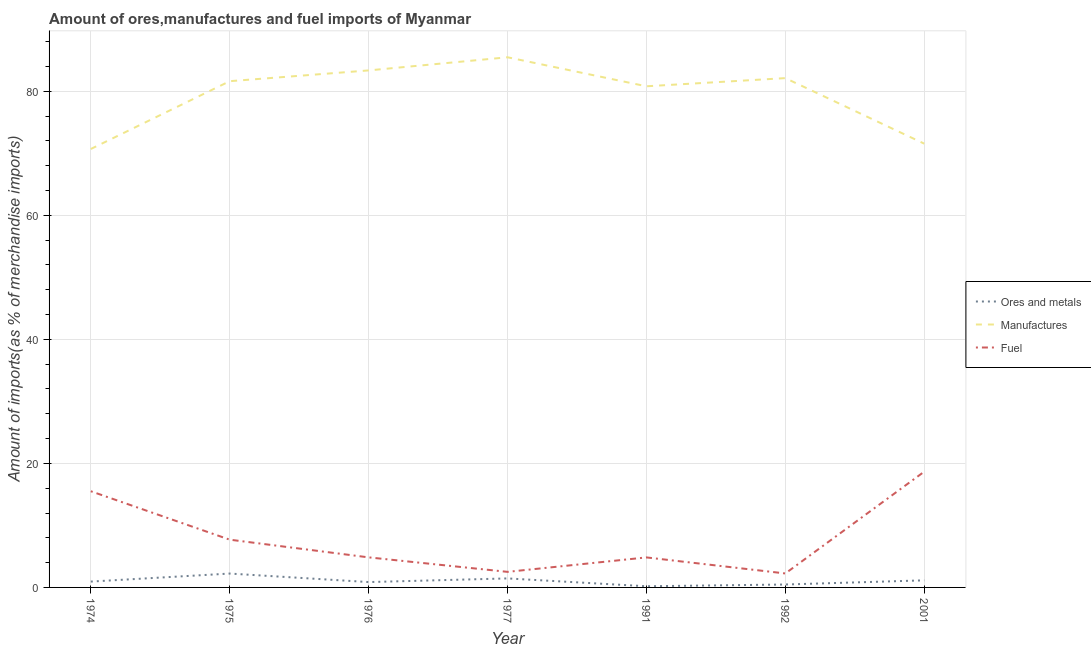Is the number of lines equal to the number of legend labels?
Make the answer very short. Yes. What is the percentage of manufactures imports in 1977?
Keep it short and to the point. 85.5. Across all years, what is the maximum percentage of ores and metals imports?
Your response must be concise. 2.24. Across all years, what is the minimum percentage of ores and metals imports?
Offer a very short reply. 0.19. In which year was the percentage of ores and metals imports maximum?
Your answer should be compact. 1975. In which year was the percentage of ores and metals imports minimum?
Your response must be concise. 1991. What is the total percentage of ores and metals imports in the graph?
Offer a terse response. 7.3. What is the difference between the percentage of ores and metals imports in 1977 and that in 1991?
Offer a very short reply. 1.27. What is the difference between the percentage of manufactures imports in 1975 and the percentage of fuel imports in 1991?
Your answer should be very brief. 76.8. What is the average percentage of manufactures imports per year?
Offer a very short reply. 79.39. In the year 1975, what is the difference between the percentage of manufactures imports and percentage of fuel imports?
Offer a terse response. 73.94. In how many years, is the percentage of ores and metals imports greater than 68 %?
Make the answer very short. 0. What is the ratio of the percentage of manufactures imports in 1976 to that in 1977?
Your answer should be compact. 0.98. Is the difference between the percentage of fuel imports in 1975 and 2001 greater than the difference between the percentage of ores and metals imports in 1975 and 2001?
Provide a short and direct response. No. What is the difference between the highest and the second highest percentage of ores and metals imports?
Keep it short and to the point. 0.78. What is the difference between the highest and the lowest percentage of manufactures imports?
Your answer should be compact. 14.79. Is it the case that in every year, the sum of the percentage of ores and metals imports and percentage of manufactures imports is greater than the percentage of fuel imports?
Your answer should be very brief. Yes. Does the percentage of manufactures imports monotonically increase over the years?
Keep it short and to the point. No. Is the percentage of manufactures imports strictly greater than the percentage of ores and metals imports over the years?
Ensure brevity in your answer.  Yes. How many lines are there?
Provide a succinct answer. 3. Are the values on the major ticks of Y-axis written in scientific E-notation?
Give a very brief answer. No. Does the graph contain grids?
Provide a short and direct response. Yes. How many legend labels are there?
Keep it short and to the point. 3. What is the title of the graph?
Ensure brevity in your answer.  Amount of ores,manufactures and fuel imports of Myanmar. What is the label or title of the Y-axis?
Your answer should be very brief. Amount of imports(as % of merchandise imports). What is the Amount of imports(as % of merchandise imports) of Ores and metals in 1974?
Make the answer very short. 0.94. What is the Amount of imports(as % of merchandise imports) in Manufactures in 1974?
Ensure brevity in your answer.  70.7. What is the Amount of imports(as % of merchandise imports) in Fuel in 1974?
Offer a very short reply. 15.51. What is the Amount of imports(as % of merchandise imports) in Ores and metals in 1975?
Your response must be concise. 2.24. What is the Amount of imports(as % of merchandise imports) in Manufactures in 1975?
Keep it short and to the point. 81.64. What is the Amount of imports(as % of merchandise imports) of Fuel in 1975?
Your response must be concise. 7.7. What is the Amount of imports(as % of merchandise imports) of Ores and metals in 1976?
Offer a terse response. 0.86. What is the Amount of imports(as % of merchandise imports) in Manufactures in 1976?
Offer a very short reply. 83.38. What is the Amount of imports(as % of merchandise imports) of Fuel in 1976?
Make the answer very short. 4.85. What is the Amount of imports(as % of merchandise imports) in Ores and metals in 1977?
Offer a terse response. 1.45. What is the Amount of imports(as % of merchandise imports) of Manufactures in 1977?
Provide a succinct answer. 85.5. What is the Amount of imports(as % of merchandise imports) in Fuel in 1977?
Your answer should be compact. 2.51. What is the Amount of imports(as % of merchandise imports) in Ores and metals in 1991?
Keep it short and to the point. 0.19. What is the Amount of imports(as % of merchandise imports) in Manufactures in 1991?
Your answer should be compact. 80.82. What is the Amount of imports(as % of merchandise imports) in Fuel in 1991?
Your answer should be compact. 4.84. What is the Amount of imports(as % of merchandise imports) in Ores and metals in 1992?
Offer a terse response. 0.47. What is the Amount of imports(as % of merchandise imports) in Manufactures in 1992?
Your answer should be very brief. 82.13. What is the Amount of imports(as % of merchandise imports) in Fuel in 1992?
Your answer should be very brief. 2.25. What is the Amount of imports(as % of merchandise imports) in Ores and metals in 2001?
Keep it short and to the point. 1.14. What is the Amount of imports(as % of merchandise imports) in Manufactures in 2001?
Your answer should be compact. 71.57. What is the Amount of imports(as % of merchandise imports) of Fuel in 2001?
Your answer should be compact. 18.67. Across all years, what is the maximum Amount of imports(as % of merchandise imports) in Ores and metals?
Offer a very short reply. 2.24. Across all years, what is the maximum Amount of imports(as % of merchandise imports) of Manufactures?
Provide a short and direct response. 85.5. Across all years, what is the maximum Amount of imports(as % of merchandise imports) in Fuel?
Offer a terse response. 18.67. Across all years, what is the minimum Amount of imports(as % of merchandise imports) in Ores and metals?
Your answer should be compact. 0.19. Across all years, what is the minimum Amount of imports(as % of merchandise imports) of Manufactures?
Offer a terse response. 70.7. Across all years, what is the minimum Amount of imports(as % of merchandise imports) of Fuel?
Give a very brief answer. 2.25. What is the total Amount of imports(as % of merchandise imports) in Ores and metals in the graph?
Offer a terse response. 7.3. What is the total Amount of imports(as % of merchandise imports) in Manufactures in the graph?
Keep it short and to the point. 555.73. What is the total Amount of imports(as % of merchandise imports) in Fuel in the graph?
Ensure brevity in your answer.  56.33. What is the difference between the Amount of imports(as % of merchandise imports) of Ores and metals in 1974 and that in 1975?
Provide a succinct answer. -1.29. What is the difference between the Amount of imports(as % of merchandise imports) of Manufactures in 1974 and that in 1975?
Give a very brief answer. -10.94. What is the difference between the Amount of imports(as % of merchandise imports) of Fuel in 1974 and that in 1975?
Give a very brief answer. 7.81. What is the difference between the Amount of imports(as % of merchandise imports) in Ores and metals in 1974 and that in 1976?
Your answer should be very brief. 0.08. What is the difference between the Amount of imports(as % of merchandise imports) in Manufactures in 1974 and that in 1976?
Your response must be concise. -12.67. What is the difference between the Amount of imports(as % of merchandise imports) in Fuel in 1974 and that in 1976?
Provide a short and direct response. 10.66. What is the difference between the Amount of imports(as % of merchandise imports) of Ores and metals in 1974 and that in 1977?
Offer a terse response. -0.51. What is the difference between the Amount of imports(as % of merchandise imports) of Manufactures in 1974 and that in 1977?
Ensure brevity in your answer.  -14.79. What is the difference between the Amount of imports(as % of merchandise imports) of Fuel in 1974 and that in 1977?
Give a very brief answer. 13. What is the difference between the Amount of imports(as % of merchandise imports) in Ores and metals in 1974 and that in 1991?
Provide a short and direct response. 0.75. What is the difference between the Amount of imports(as % of merchandise imports) in Manufactures in 1974 and that in 1991?
Offer a terse response. -10.11. What is the difference between the Amount of imports(as % of merchandise imports) in Fuel in 1974 and that in 1991?
Ensure brevity in your answer.  10.67. What is the difference between the Amount of imports(as % of merchandise imports) of Ores and metals in 1974 and that in 1992?
Offer a terse response. 0.47. What is the difference between the Amount of imports(as % of merchandise imports) in Manufactures in 1974 and that in 1992?
Your answer should be compact. -11.43. What is the difference between the Amount of imports(as % of merchandise imports) in Fuel in 1974 and that in 1992?
Keep it short and to the point. 13.26. What is the difference between the Amount of imports(as % of merchandise imports) in Ores and metals in 1974 and that in 2001?
Offer a very short reply. -0.2. What is the difference between the Amount of imports(as % of merchandise imports) of Manufactures in 1974 and that in 2001?
Ensure brevity in your answer.  -0.86. What is the difference between the Amount of imports(as % of merchandise imports) of Fuel in 1974 and that in 2001?
Provide a short and direct response. -3.16. What is the difference between the Amount of imports(as % of merchandise imports) in Ores and metals in 1975 and that in 1976?
Provide a short and direct response. 1.37. What is the difference between the Amount of imports(as % of merchandise imports) of Manufactures in 1975 and that in 1976?
Your answer should be compact. -1.74. What is the difference between the Amount of imports(as % of merchandise imports) in Fuel in 1975 and that in 1976?
Offer a very short reply. 2.85. What is the difference between the Amount of imports(as % of merchandise imports) in Ores and metals in 1975 and that in 1977?
Keep it short and to the point. 0.78. What is the difference between the Amount of imports(as % of merchandise imports) in Manufactures in 1975 and that in 1977?
Offer a terse response. -3.86. What is the difference between the Amount of imports(as % of merchandise imports) of Fuel in 1975 and that in 1977?
Keep it short and to the point. 5.19. What is the difference between the Amount of imports(as % of merchandise imports) of Ores and metals in 1975 and that in 1991?
Make the answer very short. 2.05. What is the difference between the Amount of imports(as % of merchandise imports) of Manufactures in 1975 and that in 1991?
Provide a short and direct response. 0.82. What is the difference between the Amount of imports(as % of merchandise imports) in Fuel in 1975 and that in 1991?
Offer a terse response. 2.86. What is the difference between the Amount of imports(as % of merchandise imports) in Ores and metals in 1975 and that in 1992?
Your response must be concise. 1.77. What is the difference between the Amount of imports(as % of merchandise imports) in Manufactures in 1975 and that in 1992?
Provide a succinct answer. -0.49. What is the difference between the Amount of imports(as % of merchandise imports) in Fuel in 1975 and that in 1992?
Your answer should be compact. 5.45. What is the difference between the Amount of imports(as % of merchandise imports) of Ores and metals in 1975 and that in 2001?
Keep it short and to the point. 1.09. What is the difference between the Amount of imports(as % of merchandise imports) of Manufactures in 1975 and that in 2001?
Provide a succinct answer. 10.07. What is the difference between the Amount of imports(as % of merchandise imports) in Fuel in 1975 and that in 2001?
Your answer should be compact. -10.97. What is the difference between the Amount of imports(as % of merchandise imports) in Ores and metals in 1976 and that in 1977?
Offer a terse response. -0.59. What is the difference between the Amount of imports(as % of merchandise imports) of Manufactures in 1976 and that in 1977?
Your response must be concise. -2.12. What is the difference between the Amount of imports(as % of merchandise imports) of Fuel in 1976 and that in 1977?
Provide a succinct answer. 2.34. What is the difference between the Amount of imports(as % of merchandise imports) in Ores and metals in 1976 and that in 1991?
Offer a terse response. 0.68. What is the difference between the Amount of imports(as % of merchandise imports) of Manufactures in 1976 and that in 1991?
Provide a succinct answer. 2.56. What is the difference between the Amount of imports(as % of merchandise imports) in Fuel in 1976 and that in 1991?
Offer a very short reply. 0.01. What is the difference between the Amount of imports(as % of merchandise imports) of Ores and metals in 1976 and that in 1992?
Your answer should be very brief. 0.39. What is the difference between the Amount of imports(as % of merchandise imports) in Manufactures in 1976 and that in 1992?
Give a very brief answer. 1.24. What is the difference between the Amount of imports(as % of merchandise imports) in Fuel in 1976 and that in 1992?
Your answer should be compact. 2.59. What is the difference between the Amount of imports(as % of merchandise imports) in Ores and metals in 1976 and that in 2001?
Ensure brevity in your answer.  -0.28. What is the difference between the Amount of imports(as % of merchandise imports) of Manufactures in 1976 and that in 2001?
Keep it short and to the point. 11.81. What is the difference between the Amount of imports(as % of merchandise imports) of Fuel in 1976 and that in 2001?
Make the answer very short. -13.82. What is the difference between the Amount of imports(as % of merchandise imports) in Ores and metals in 1977 and that in 1991?
Provide a short and direct response. 1.27. What is the difference between the Amount of imports(as % of merchandise imports) in Manufactures in 1977 and that in 1991?
Make the answer very short. 4.68. What is the difference between the Amount of imports(as % of merchandise imports) in Fuel in 1977 and that in 1991?
Ensure brevity in your answer.  -2.33. What is the difference between the Amount of imports(as % of merchandise imports) in Ores and metals in 1977 and that in 1992?
Offer a very short reply. 0.98. What is the difference between the Amount of imports(as % of merchandise imports) of Manufactures in 1977 and that in 1992?
Provide a short and direct response. 3.36. What is the difference between the Amount of imports(as % of merchandise imports) in Fuel in 1977 and that in 1992?
Your response must be concise. 0.26. What is the difference between the Amount of imports(as % of merchandise imports) in Ores and metals in 1977 and that in 2001?
Keep it short and to the point. 0.31. What is the difference between the Amount of imports(as % of merchandise imports) of Manufactures in 1977 and that in 2001?
Ensure brevity in your answer.  13.93. What is the difference between the Amount of imports(as % of merchandise imports) of Fuel in 1977 and that in 2001?
Your answer should be very brief. -16.16. What is the difference between the Amount of imports(as % of merchandise imports) in Ores and metals in 1991 and that in 1992?
Give a very brief answer. -0.28. What is the difference between the Amount of imports(as % of merchandise imports) in Manufactures in 1991 and that in 1992?
Your answer should be very brief. -1.32. What is the difference between the Amount of imports(as % of merchandise imports) of Fuel in 1991 and that in 1992?
Provide a short and direct response. 2.59. What is the difference between the Amount of imports(as % of merchandise imports) of Ores and metals in 1991 and that in 2001?
Provide a short and direct response. -0.95. What is the difference between the Amount of imports(as % of merchandise imports) of Manufactures in 1991 and that in 2001?
Make the answer very short. 9.25. What is the difference between the Amount of imports(as % of merchandise imports) in Fuel in 1991 and that in 2001?
Keep it short and to the point. -13.83. What is the difference between the Amount of imports(as % of merchandise imports) in Ores and metals in 1992 and that in 2001?
Your response must be concise. -0.67. What is the difference between the Amount of imports(as % of merchandise imports) of Manufactures in 1992 and that in 2001?
Offer a very short reply. 10.57. What is the difference between the Amount of imports(as % of merchandise imports) of Fuel in 1992 and that in 2001?
Provide a succinct answer. -16.42. What is the difference between the Amount of imports(as % of merchandise imports) of Ores and metals in 1974 and the Amount of imports(as % of merchandise imports) of Manufactures in 1975?
Provide a succinct answer. -80.7. What is the difference between the Amount of imports(as % of merchandise imports) of Ores and metals in 1974 and the Amount of imports(as % of merchandise imports) of Fuel in 1975?
Your answer should be very brief. -6.76. What is the difference between the Amount of imports(as % of merchandise imports) of Manufactures in 1974 and the Amount of imports(as % of merchandise imports) of Fuel in 1975?
Keep it short and to the point. 63. What is the difference between the Amount of imports(as % of merchandise imports) of Ores and metals in 1974 and the Amount of imports(as % of merchandise imports) of Manufactures in 1976?
Give a very brief answer. -82.43. What is the difference between the Amount of imports(as % of merchandise imports) in Ores and metals in 1974 and the Amount of imports(as % of merchandise imports) in Fuel in 1976?
Your answer should be very brief. -3.91. What is the difference between the Amount of imports(as % of merchandise imports) of Manufactures in 1974 and the Amount of imports(as % of merchandise imports) of Fuel in 1976?
Your answer should be compact. 65.86. What is the difference between the Amount of imports(as % of merchandise imports) in Ores and metals in 1974 and the Amount of imports(as % of merchandise imports) in Manufactures in 1977?
Your answer should be very brief. -84.55. What is the difference between the Amount of imports(as % of merchandise imports) of Ores and metals in 1974 and the Amount of imports(as % of merchandise imports) of Fuel in 1977?
Provide a short and direct response. -1.57. What is the difference between the Amount of imports(as % of merchandise imports) of Manufactures in 1974 and the Amount of imports(as % of merchandise imports) of Fuel in 1977?
Keep it short and to the point. 68.19. What is the difference between the Amount of imports(as % of merchandise imports) of Ores and metals in 1974 and the Amount of imports(as % of merchandise imports) of Manufactures in 1991?
Make the answer very short. -79.88. What is the difference between the Amount of imports(as % of merchandise imports) in Ores and metals in 1974 and the Amount of imports(as % of merchandise imports) in Fuel in 1991?
Provide a succinct answer. -3.9. What is the difference between the Amount of imports(as % of merchandise imports) in Manufactures in 1974 and the Amount of imports(as % of merchandise imports) in Fuel in 1991?
Your answer should be very brief. 65.86. What is the difference between the Amount of imports(as % of merchandise imports) of Ores and metals in 1974 and the Amount of imports(as % of merchandise imports) of Manufactures in 1992?
Give a very brief answer. -81.19. What is the difference between the Amount of imports(as % of merchandise imports) in Ores and metals in 1974 and the Amount of imports(as % of merchandise imports) in Fuel in 1992?
Give a very brief answer. -1.31. What is the difference between the Amount of imports(as % of merchandise imports) of Manufactures in 1974 and the Amount of imports(as % of merchandise imports) of Fuel in 1992?
Ensure brevity in your answer.  68.45. What is the difference between the Amount of imports(as % of merchandise imports) in Ores and metals in 1974 and the Amount of imports(as % of merchandise imports) in Manufactures in 2001?
Provide a short and direct response. -70.62. What is the difference between the Amount of imports(as % of merchandise imports) in Ores and metals in 1974 and the Amount of imports(as % of merchandise imports) in Fuel in 2001?
Provide a short and direct response. -17.73. What is the difference between the Amount of imports(as % of merchandise imports) of Manufactures in 1974 and the Amount of imports(as % of merchandise imports) of Fuel in 2001?
Offer a very short reply. 52.04. What is the difference between the Amount of imports(as % of merchandise imports) in Ores and metals in 1975 and the Amount of imports(as % of merchandise imports) in Manufactures in 1976?
Keep it short and to the point. -81.14. What is the difference between the Amount of imports(as % of merchandise imports) in Ores and metals in 1975 and the Amount of imports(as % of merchandise imports) in Fuel in 1976?
Your response must be concise. -2.61. What is the difference between the Amount of imports(as % of merchandise imports) of Manufactures in 1975 and the Amount of imports(as % of merchandise imports) of Fuel in 1976?
Offer a very short reply. 76.79. What is the difference between the Amount of imports(as % of merchandise imports) in Ores and metals in 1975 and the Amount of imports(as % of merchandise imports) in Manufactures in 1977?
Ensure brevity in your answer.  -83.26. What is the difference between the Amount of imports(as % of merchandise imports) of Ores and metals in 1975 and the Amount of imports(as % of merchandise imports) of Fuel in 1977?
Keep it short and to the point. -0.27. What is the difference between the Amount of imports(as % of merchandise imports) in Manufactures in 1975 and the Amount of imports(as % of merchandise imports) in Fuel in 1977?
Keep it short and to the point. 79.13. What is the difference between the Amount of imports(as % of merchandise imports) of Ores and metals in 1975 and the Amount of imports(as % of merchandise imports) of Manufactures in 1991?
Your response must be concise. -78.58. What is the difference between the Amount of imports(as % of merchandise imports) in Ores and metals in 1975 and the Amount of imports(as % of merchandise imports) in Fuel in 1991?
Provide a short and direct response. -2.6. What is the difference between the Amount of imports(as % of merchandise imports) of Manufactures in 1975 and the Amount of imports(as % of merchandise imports) of Fuel in 1991?
Provide a short and direct response. 76.8. What is the difference between the Amount of imports(as % of merchandise imports) in Ores and metals in 1975 and the Amount of imports(as % of merchandise imports) in Manufactures in 1992?
Offer a terse response. -79.9. What is the difference between the Amount of imports(as % of merchandise imports) of Ores and metals in 1975 and the Amount of imports(as % of merchandise imports) of Fuel in 1992?
Your response must be concise. -0.02. What is the difference between the Amount of imports(as % of merchandise imports) of Manufactures in 1975 and the Amount of imports(as % of merchandise imports) of Fuel in 1992?
Your response must be concise. 79.39. What is the difference between the Amount of imports(as % of merchandise imports) of Ores and metals in 1975 and the Amount of imports(as % of merchandise imports) of Manufactures in 2001?
Your answer should be compact. -69.33. What is the difference between the Amount of imports(as % of merchandise imports) of Ores and metals in 1975 and the Amount of imports(as % of merchandise imports) of Fuel in 2001?
Ensure brevity in your answer.  -16.43. What is the difference between the Amount of imports(as % of merchandise imports) in Manufactures in 1975 and the Amount of imports(as % of merchandise imports) in Fuel in 2001?
Your answer should be very brief. 62.97. What is the difference between the Amount of imports(as % of merchandise imports) in Ores and metals in 1976 and the Amount of imports(as % of merchandise imports) in Manufactures in 1977?
Your answer should be compact. -84.63. What is the difference between the Amount of imports(as % of merchandise imports) in Ores and metals in 1976 and the Amount of imports(as % of merchandise imports) in Fuel in 1977?
Ensure brevity in your answer.  -1.65. What is the difference between the Amount of imports(as % of merchandise imports) of Manufactures in 1976 and the Amount of imports(as % of merchandise imports) of Fuel in 1977?
Provide a succinct answer. 80.87. What is the difference between the Amount of imports(as % of merchandise imports) of Ores and metals in 1976 and the Amount of imports(as % of merchandise imports) of Manufactures in 1991?
Provide a succinct answer. -79.95. What is the difference between the Amount of imports(as % of merchandise imports) of Ores and metals in 1976 and the Amount of imports(as % of merchandise imports) of Fuel in 1991?
Your answer should be compact. -3.98. What is the difference between the Amount of imports(as % of merchandise imports) of Manufactures in 1976 and the Amount of imports(as % of merchandise imports) of Fuel in 1991?
Your answer should be compact. 78.54. What is the difference between the Amount of imports(as % of merchandise imports) in Ores and metals in 1976 and the Amount of imports(as % of merchandise imports) in Manufactures in 1992?
Provide a short and direct response. -81.27. What is the difference between the Amount of imports(as % of merchandise imports) of Ores and metals in 1976 and the Amount of imports(as % of merchandise imports) of Fuel in 1992?
Offer a very short reply. -1.39. What is the difference between the Amount of imports(as % of merchandise imports) of Manufactures in 1976 and the Amount of imports(as % of merchandise imports) of Fuel in 1992?
Offer a very short reply. 81.12. What is the difference between the Amount of imports(as % of merchandise imports) in Ores and metals in 1976 and the Amount of imports(as % of merchandise imports) in Manufactures in 2001?
Your answer should be very brief. -70.7. What is the difference between the Amount of imports(as % of merchandise imports) in Ores and metals in 1976 and the Amount of imports(as % of merchandise imports) in Fuel in 2001?
Offer a terse response. -17.8. What is the difference between the Amount of imports(as % of merchandise imports) in Manufactures in 1976 and the Amount of imports(as % of merchandise imports) in Fuel in 2001?
Keep it short and to the point. 64.71. What is the difference between the Amount of imports(as % of merchandise imports) of Ores and metals in 1977 and the Amount of imports(as % of merchandise imports) of Manufactures in 1991?
Keep it short and to the point. -79.36. What is the difference between the Amount of imports(as % of merchandise imports) in Ores and metals in 1977 and the Amount of imports(as % of merchandise imports) in Fuel in 1991?
Provide a short and direct response. -3.39. What is the difference between the Amount of imports(as % of merchandise imports) of Manufactures in 1977 and the Amount of imports(as % of merchandise imports) of Fuel in 1991?
Provide a succinct answer. 80.66. What is the difference between the Amount of imports(as % of merchandise imports) in Ores and metals in 1977 and the Amount of imports(as % of merchandise imports) in Manufactures in 1992?
Provide a short and direct response. -80.68. What is the difference between the Amount of imports(as % of merchandise imports) in Ores and metals in 1977 and the Amount of imports(as % of merchandise imports) in Fuel in 1992?
Your answer should be very brief. -0.8. What is the difference between the Amount of imports(as % of merchandise imports) in Manufactures in 1977 and the Amount of imports(as % of merchandise imports) in Fuel in 1992?
Provide a short and direct response. 83.24. What is the difference between the Amount of imports(as % of merchandise imports) of Ores and metals in 1977 and the Amount of imports(as % of merchandise imports) of Manufactures in 2001?
Offer a terse response. -70.11. What is the difference between the Amount of imports(as % of merchandise imports) in Ores and metals in 1977 and the Amount of imports(as % of merchandise imports) in Fuel in 2001?
Ensure brevity in your answer.  -17.22. What is the difference between the Amount of imports(as % of merchandise imports) in Manufactures in 1977 and the Amount of imports(as % of merchandise imports) in Fuel in 2001?
Your answer should be compact. 66.83. What is the difference between the Amount of imports(as % of merchandise imports) in Ores and metals in 1991 and the Amount of imports(as % of merchandise imports) in Manufactures in 1992?
Offer a very short reply. -81.95. What is the difference between the Amount of imports(as % of merchandise imports) of Ores and metals in 1991 and the Amount of imports(as % of merchandise imports) of Fuel in 1992?
Provide a succinct answer. -2.07. What is the difference between the Amount of imports(as % of merchandise imports) of Manufactures in 1991 and the Amount of imports(as % of merchandise imports) of Fuel in 1992?
Provide a succinct answer. 78.56. What is the difference between the Amount of imports(as % of merchandise imports) of Ores and metals in 1991 and the Amount of imports(as % of merchandise imports) of Manufactures in 2001?
Your answer should be very brief. -71.38. What is the difference between the Amount of imports(as % of merchandise imports) of Ores and metals in 1991 and the Amount of imports(as % of merchandise imports) of Fuel in 2001?
Keep it short and to the point. -18.48. What is the difference between the Amount of imports(as % of merchandise imports) of Manufactures in 1991 and the Amount of imports(as % of merchandise imports) of Fuel in 2001?
Keep it short and to the point. 62.15. What is the difference between the Amount of imports(as % of merchandise imports) of Ores and metals in 1992 and the Amount of imports(as % of merchandise imports) of Manufactures in 2001?
Give a very brief answer. -71.09. What is the difference between the Amount of imports(as % of merchandise imports) in Ores and metals in 1992 and the Amount of imports(as % of merchandise imports) in Fuel in 2001?
Give a very brief answer. -18.2. What is the difference between the Amount of imports(as % of merchandise imports) in Manufactures in 1992 and the Amount of imports(as % of merchandise imports) in Fuel in 2001?
Provide a short and direct response. 63.47. What is the average Amount of imports(as % of merchandise imports) of Ores and metals per year?
Keep it short and to the point. 1.04. What is the average Amount of imports(as % of merchandise imports) of Manufactures per year?
Your answer should be very brief. 79.39. What is the average Amount of imports(as % of merchandise imports) in Fuel per year?
Provide a succinct answer. 8.05. In the year 1974, what is the difference between the Amount of imports(as % of merchandise imports) of Ores and metals and Amount of imports(as % of merchandise imports) of Manufactures?
Your response must be concise. -69.76. In the year 1974, what is the difference between the Amount of imports(as % of merchandise imports) of Ores and metals and Amount of imports(as % of merchandise imports) of Fuel?
Provide a short and direct response. -14.57. In the year 1974, what is the difference between the Amount of imports(as % of merchandise imports) in Manufactures and Amount of imports(as % of merchandise imports) in Fuel?
Keep it short and to the point. 55.19. In the year 1975, what is the difference between the Amount of imports(as % of merchandise imports) in Ores and metals and Amount of imports(as % of merchandise imports) in Manufactures?
Provide a short and direct response. -79.4. In the year 1975, what is the difference between the Amount of imports(as % of merchandise imports) in Ores and metals and Amount of imports(as % of merchandise imports) in Fuel?
Make the answer very short. -5.46. In the year 1975, what is the difference between the Amount of imports(as % of merchandise imports) in Manufactures and Amount of imports(as % of merchandise imports) in Fuel?
Keep it short and to the point. 73.94. In the year 1976, what is the difference between the Amount of imports(as % of merchandise imports) of Ores and metals and Amount of imports(as % of merchandise imports) of Manufactures?
Give a very brief answer. -82.51. In the year 1976, what is the difference between the Amount of imports(as % of merchandise imports) in Ores and metals and Amount of imports(as % of merchandise imports) in Fuel?
Give a very brief answer. -3.98. In the year 1976, what is the difference between the Amount of imports(as % of merchandise imports) of Manufactures and Amount of imports(as % of merchandise imports) of Fuel?
Offer a very short reply. 78.53. In the year 1977, what is the difference between the Amount of imports(as % of merchandise imports) of Ores and metals and Amount of imports(as % of merchandise imports) of Manufactures?
Ensure brevity in your answer.  -84.04. In the year 1977, what is the difference between the Amount of imports(as % of merchandise imports) in Ores and metals and Amount of imports(as % of merchandise imports) in Fuel?
Provide a short and direct response. -1.06. In the year 1977, what is the difference between the Amount of imports(as % of merchandise imports) of Manufactures and Amount of imports(as % of merchandise imports) of Fuel?
Ensure brevity in your answer.  82.98. In the year 1991, what is the difference between the Amount of imports(as % of merchandise imports) in Ores and metals and Amount of imports(as % of merchandise imports) in Manufactures?
Offer a terse response. -80.63. In the year 1991, what is the difference between the Amount of imports(as % of merchandise imports) in Ores and metals and Amount of imports(as % of merchandise imports) in Fuel?
Ensure brevity in your answer.  -4.65. In the year 1991, what is the difference between the Amount of imports(as % of merchandise imports) of Manufactures and Amount of imports(as % of merchandise imports) of Fuel?
Keep it short and to the point. 75.98. In the year 1992, what is the difference between the Amount of imports(as % of merchandise imports) in Ores and metals and Amount of imports(as % of merchandise imports) in Manufactures?
Make the answer very short. -81.66. In the year 1992, what is the difference between the Amount of imports(as % of merchandise imports) in Ores and metals and Amount of imports(as % of merchandise imports) in Fuel?
Offer a very short reply. -1.78. In the year 1992, what is the difference between the Amount of imports(as % of merchandise imports) of Manufactures and Amount of imports(as % of merchandise imports) of Fuel?
Keep it short and to the point. 79.88. In the year 2001, what is the difference between the Amount of imports(as % of merchandise imports) in Ores and metals and Amount of imports(as % of merchandise imports) in Manufactures?
Ensure brevity in your answer.  -70.42. In the year 2001, what is the difference between the Amount of imports(as % of merchandise imports) of Ores and metals and Amount of imports(as % of merchandise imports) of Fuel?
Make the answer very short. -17.53. In the year 2001, what is the difference between the Amount of imports(as % of merchandise imports) of Manufactures and Amount of imports(as % of merchandise imports) of Fuel?
Keep it short and to the point. 52.9. What is the ratio of the Amount of imports(as % of merchandise imports) in Ores and metals in 1974 to that in 1975?
Your answer should be compact. 0.42. What is the ratio of the Amount of imports(as % of merchandise imports) of Manufactures in 1974 to that in 1975?
Offer a very short reply. 0.87. What is the ratio of the Amount of imports(as % of merchandise imports) in Fuel in 1974 to that in 1975?
Keep it short and to the point. 2.01. What is the ratio of the Amount of imports(as % of merchandise imports) in Ores and metals in 1974 to that in 1976?
Offer a terse response. 1.09. What is the ratio of the Amount of imports(as % of merchandise imports) in Manufactures in 1974 to that in 1976?
Provide a succinct answer. 0.85. What is the ratio of the Amount of imports(as % of merchandise imports) of Ores and metals in 1974 to that in 1977?
Your answer should be compact. 0.65. What is the ratio of the Amount of imports(as % of merchandise imports) of Manufactures in 1974 to that in 1977?
Offer a terse response. 0.83. What is the ratio of the Amount of imports(as % of merchandise imports) in Fuel in 1974 to that in 1977?
Give a very brief answer. 6.18. What is the ratio of the Amount of imports(as % of merchandise imports) of Ores and metals in 1974 to that in 1991?
Ensure brevity in your answer.  5.01. What is the ratio of the Amount of imports(as % of merchandise imports) in Manufactures in 1974 to that in 1991?
Ensure brevity in your answer.  0.87. What is the ratio of the Amount of imports(as % of merchandise imports) in Fuel in 1974 to that in 1991?
Offer a very short reply. 3.21. What is the ratio of the Amount of imports(as % of merchandise imports) of Ores and metals in 1974 to that in 1992?
Keep it short and to the point. 2. What is the ratio of the Amount of imports(as % of merchandise imports) of Manufactures in 1974 to that in 1992?
Provide a short and direct response. 0.86. What is the ratio of the Amount of imports(as % of merchandise imports) of Fuel in 1974 to that in 1992?
Your answer should be compact. 6.88. What is the ratio of the Amount of imports(as % of merchandise imports) in Ores and metals in 1974 to that in 2001?
Provide a succinct answer. 0.82. What is the ratio of the Amount of imports(as % of merchandise imports) in Manufactures in 1974 to that in 2001?
Provide a succinct answer. 0.99. What is the ratio of the Amount of imports(as % of merchandise imports) in Fuel in 1974 to that in 2001?
Give a very brief answer. 0.83. What is the ratio of the Amount of imports(as % of merchandise imports) of Ores and metals in 1975 to that in 1976?
Your response must be concise. 2.59. What is the ratio of the Amount of imports(as % of merchandise imports) of Manufactures in 1975 to that in 1976?
Provide a short and direct response. 0.98. What is the ratio of the Amount of imports(as % of merchandise imports) of Fuel in 1975 to that in 1976?
Your answer should be very brief. 1.59. What is the ratio of the Amount of imports(as % of merchandise imports) in Ores and metals in 1975 to that in 1977?
Offer a terse response. 1.54. What is the ratio of the Amount of imports(as % of merchandise imports) of Manufactures in 1975 to that in 1977?
Give a very brief answer. 0.95. What is the ratio of the Amount of imports(as % of merchandise imports) of Fuel in 1975 to that in 1977?
Give a very brief answer. 3.07. What is the ratio of the Amount of imports(as % of merchandise imports) in Ores and metals in 1975 to that in 1991?
Make the answer very short. 11.9. What is the ratio of the Amount of imports(as % of merchandise imports) in Manufactures in 1975 to that in 1991?
Ensure brevity in your answer.  1.01. What is the ratio of the Amount of imports(as % of merchandise imports) of Fuel in 1975 to that in 1991?
Your response must be concise. 1.59. What is the ratio of the Amount of imports(as % of merchandise imports) in Ores and metals in 1975 to that in 1992?
Your answer should be very brief. 4.75. What is the ratio of the Amount of imports(as % of merchandise imports) in Fuel in 1975 to that in 1992?
Offer a terse response. 3.42. What is the ratio of the Amount of imports(as % of merchandise imports) in Ores and metals in 1975 to that in 2001?
Provide a succinct answer. 1.96. What is the ratio of the Amount of imports(as % of merchandise imports) of Manufactures in 1975 to that in 2001?
Give a very brief answer. 1.14. What is the ratio of the Amount of imports(as % of merchandise imports) in Fuel in 1975 to that in 2001?
Ensure brevity in your answer.  0.41. What is the ratio of the Amount of imports(as % of merchandise imports) in Ores and metals in 1976 to that in 1977?
Your answer should be compact. 0.59. What is the ratio of the Amount of imports(as % of merchandise imports) in Manufactures in 1976 to that in 1977?
Provide a short and direct response. 0.98. What is the ratio of the Amount of imports(as % of merchandise imports) in Fuel in 1976 to that in 1977?
Provide a short and direct response. 1.93. What is the ratio of the Amount of imports(as % of merchandise imports) of Ores and metals in 1976 to that in 1991?
Make the answer very short. 4.59. What is the ratio of the Amount of imports(as % of merchandise imports) of Manufactures in 1976 to that in 1991?
Provide a short and direct response. 1.03. What is the ratio of the Amount of imports(as % of merchandise imports) of Ores and metals in 1976 to that in 1992?
Offer a very short reply. 1.83. What is the ratio of the Amount of imports(as % of merchandise imports) in Manufactures in 1976 to that in 1992?
Your response must be concise. 1.02. What is the ratio of the Amount of imports(as % of merchandise imports) of Fuel in 1976 to that in 1992?
Offer a very short reply. 2.15. What is the ratio of the Amount of imports(as % of merchandise imports) of Ores and metals in 1976 to that in 2001?
Your answer should be compact. 0.76. What is the ratio of the Amount of imports(as % of merchandise imports) in Manufactures in 1976 to that in 2001?
Provide a succinct answer. 1.17. What is the ratio of the Amount of imports(as % of merchandise imports) in Fuel in 1976 to that in 2001?
Keep it short and to the point. 0.26. What is the ratio of the Amount of imports(as % of merchandise imports) in Ores and metals in 1977 to that in 1991?
Ensure brevity in your answer.  7.73. What is the ratio of the Amount of imports(as % of merchandise imports) of Manufactures in 1977 to that in 1991?
Keep it short and to the point. 1.06. What is the ratio of the Amount of imports(as % of merchandise imports) in Fuel in 1977 to that in 1991?
Your answer should be very brief. 0.52. What is the ratio of the Amount of imports(as % of merchandise imports) in Ores and metals in 1977 to that in 1992?
Your answer should be compact. 3.09. What is the ratio of the Amount of imports(as % of merchandise imports) of Manufactures in 1977 to that in 1992?
Provide a succinct answer. 1.04. What is the ratio of the Amount of imports(as % of merchandise imports) of Fuel in 1977 to that in 1992?
Make the answer very short. 1.11. What is the ratio of the Amount of imports(as % of merchandise imports) in Ores and metals in 1977 to that in 2001?
Your answer should be very brief. 1.27. What is the ratio of the Amount of imports(as % of merchandise imports) in Manufactures in 1977 to that in 2001?
Keep it short and to the point. 1.19. What is the ratio of the Amount of imports(as % of merchandise imports) in Fuel in 1977 to that in 2001?
Provide a succinct answer. 0.13. What is the ratio of the Amount of imports(as % of merchandise imports) of Ores and metals in 1991 to that in 1992?
Provide a succinct answer. 0.4. What is the ratio of the Amount of imports(as % of merchandise imports) in Manufactures in 1991 to that in 1992?
Make the answer very short. 0.98. What is the ratio of the Amount of imports(as % of merchandise imports) of Fuel in 1991 to that in 1992?
Your answer should be very brief. 2.15. What is the ratio of the Amount of imports(as % of merchandise imports) of Ores and metals in 1991 to that in 2001?
Your answer should be very brief. 0.16. What is the ratio of the Amount of imports(as % of merchandise imports) in Manufactures in 1991 to that in 2001?
Your answer should be compact. 1.13. What is the ratio of the Amount of imports(as % of merchandise imports) of Fuel in 1991 to that in 2001?
Provide a short and direct response. 0.26. What is the ratio of the Amount of imports(as % of merchandise imports) in Ores and metals in 1992 to that in 2001?
Your answer should be very brief. 0.41. What is the ratio of the Amount of imports(as % of merchandise imports) of Manufactures in 1992 to that in 2001?
Your answer should be compact. 1.15. What is the ratio of the Amount of imports(as % of merchandise imports) of Fuel in 1992 to that in 2001?
Ensure brevity in your answer.  0.12. What is the difference between the highest and the second highest Amount of imports(as % of merchandise imports) in Ores and metals?
Offer a very short reply. 0.78. What is the difference between the highest and the second highest Amount of imports(as % of merchandise imports) of Manufactures?
Keep it short and to the point. 2.12. What is the difference between the highest and the second highest Amount of imports(as % of merchandise imports) of Fuel?
Your answer should be compact. 3.16. What is the difference between the highest and the lowest Amount of imports(as % of merchandise imports) in Ores and metals?
Your answer should be very brief. 2.05. What is the difference between the highest and the lowest Amount of imports(as % of merchandise imports) of Manufactures?
Make the answer very short. 14.79. What is the difference between the highest and the lowest Amount of imports(as % of merchandise imports) of Fuel?
Provide a short and direct response. 16.42. 